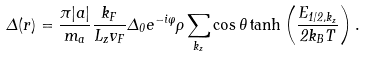Convert formula to latex. <formula><loc_0><loc_0><loc_500><loc_500>\Delta ( { r } ) = \frac { \pi | a | } { m _ { a } } \frac { k _ { F } } { L _ { z } v _ { F } } \Delta _ { 0 } e ^ { - i \varphi } \rho \sum _ { k _ { z } } \cos \theta \tanh \left ( \frac { E _ { 1 / 2 , k _ { z } } } { 2 k _ { B } T } \right ) .</formula> 